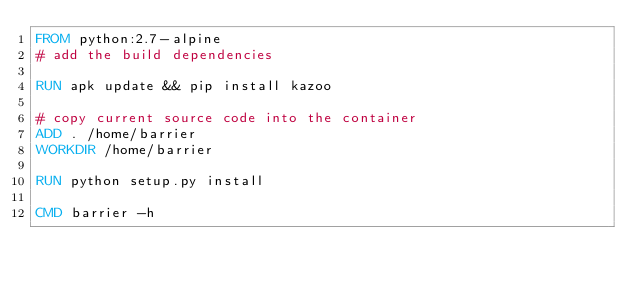<code> <loc_0><loc_0><loc_500><loc_500><_Dockerfile_>FROM python:2.7-alpine
# add the build dependencies

RUN apk update && pip install kazoo

# copy current source code into the container
ADD . /home/barrier
WORKDIR /home/barrier

RUN python setup.py install

CMD barrier -h
</code> 